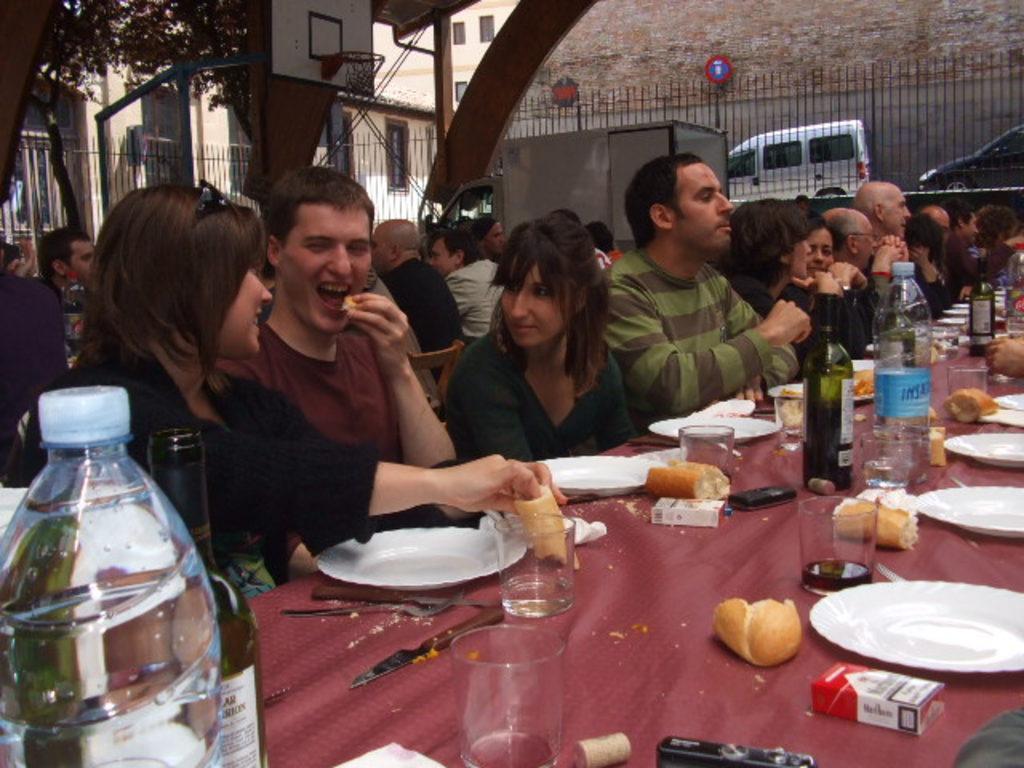Could you give a brief overview of what you see in this image? Here we can see a group of people sitting on chairs with food present on the table in front of them, there are bottles and glasses also present on the table and behind them we can see a basketball court and beside we can see a van and there are trees present 